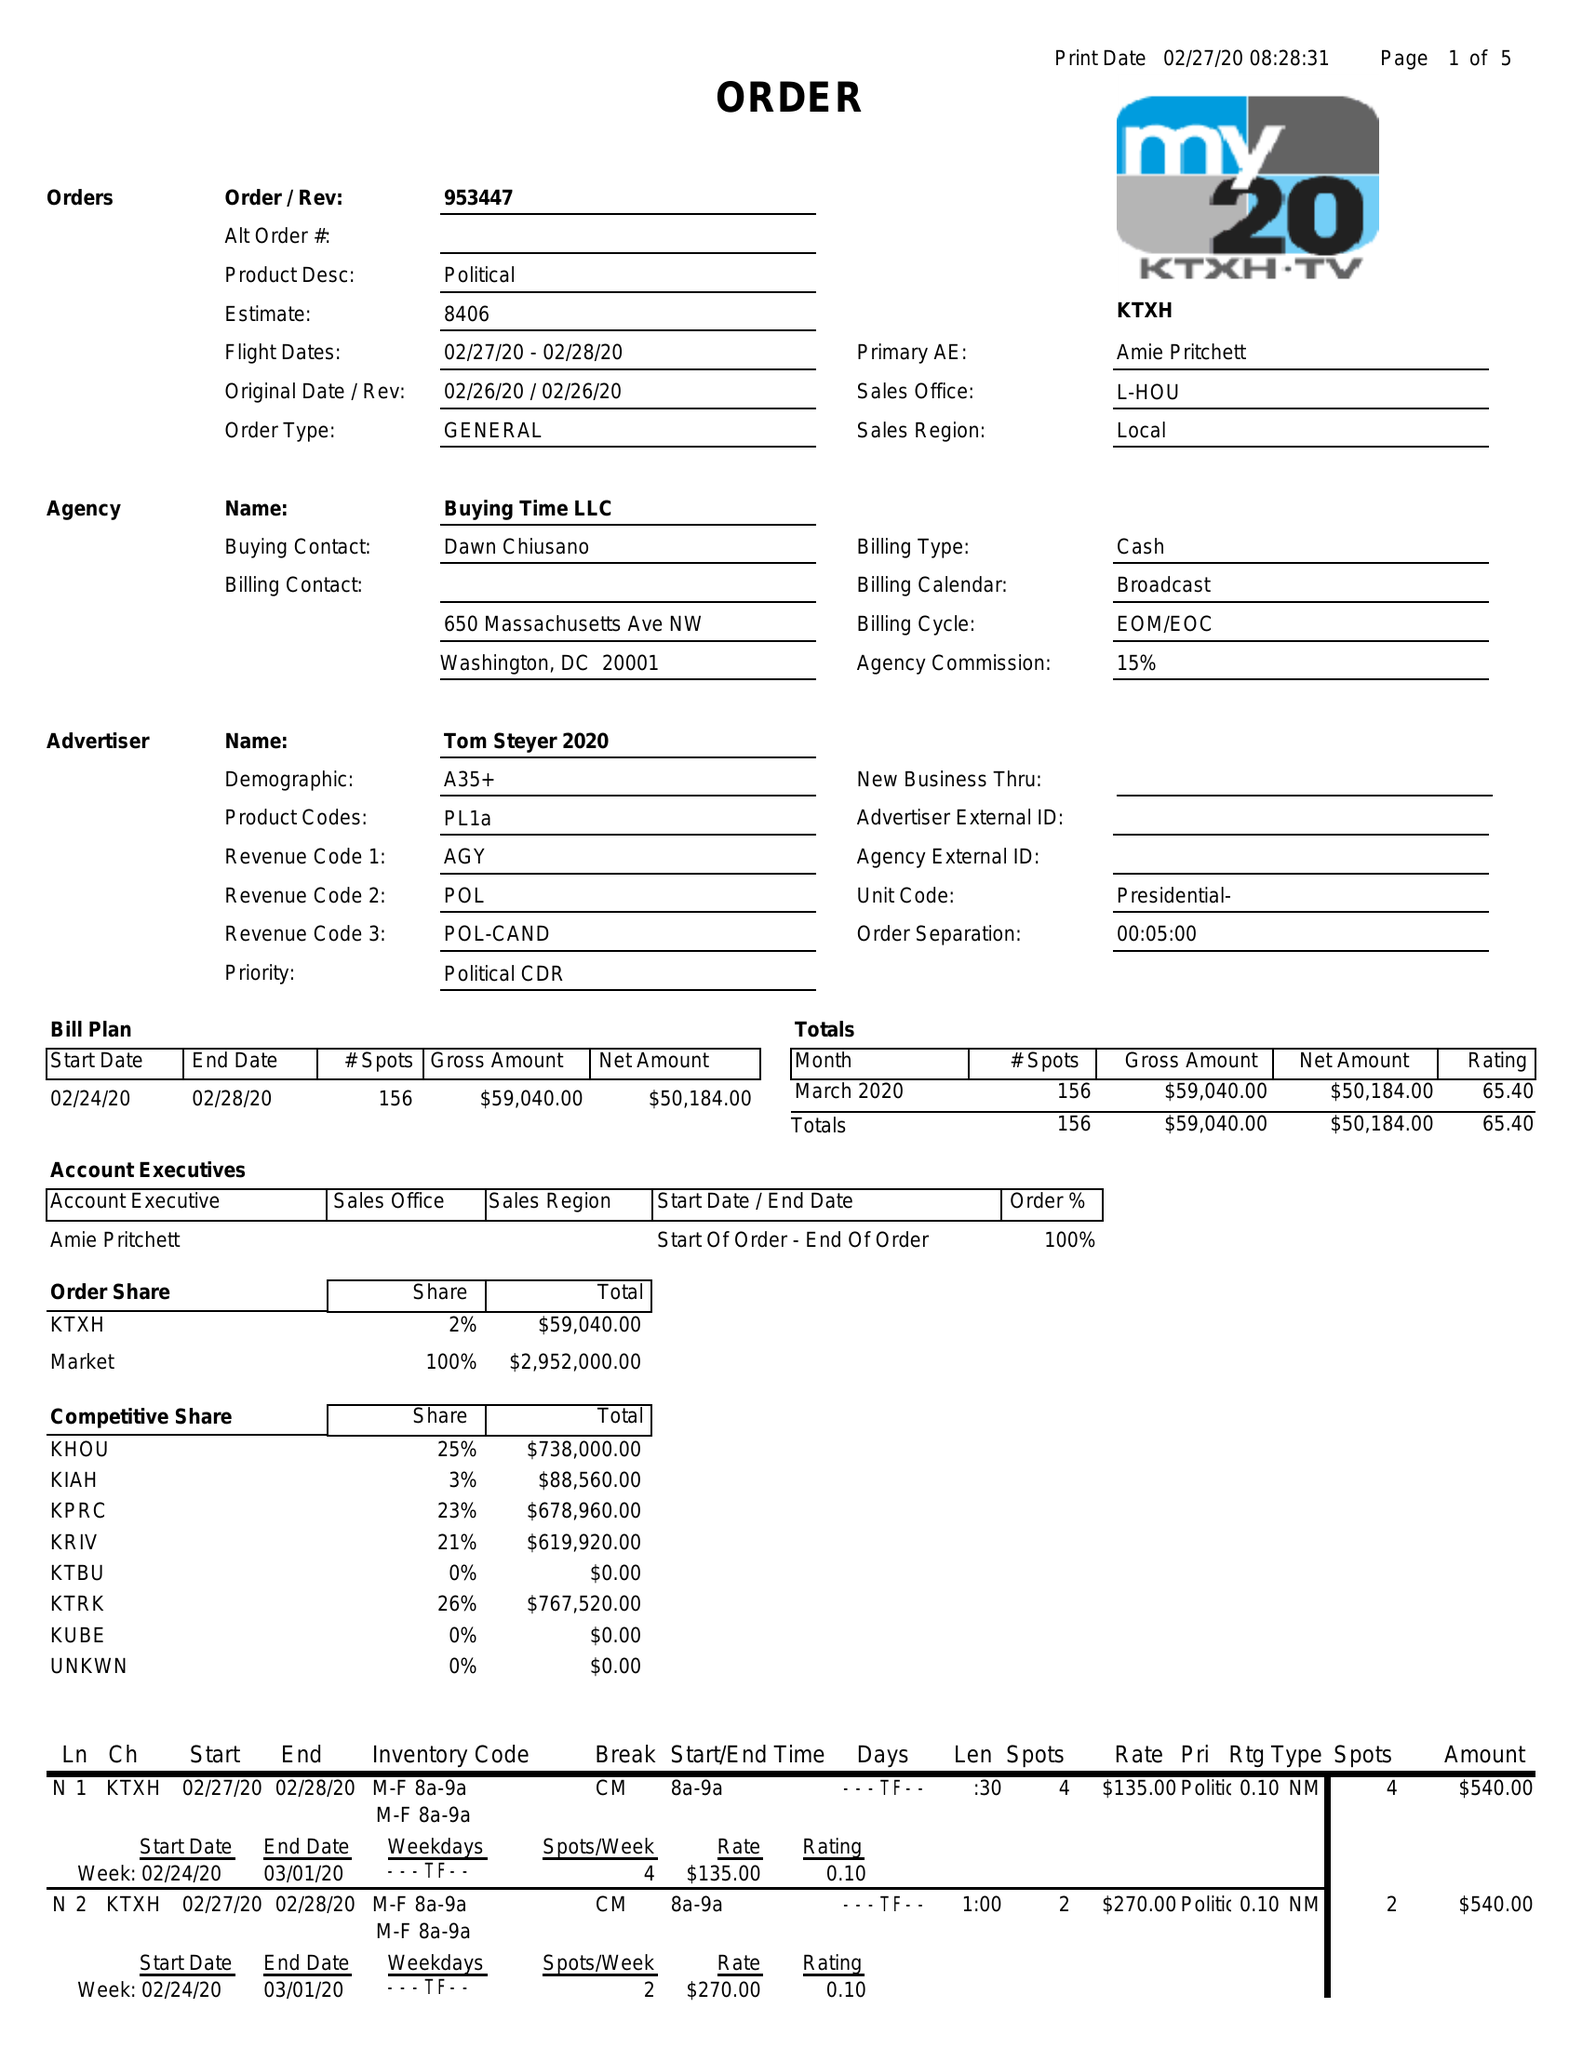What is the value for the advertiser?
Answer the question using a single word or phrase. TOM STEYER 2020 